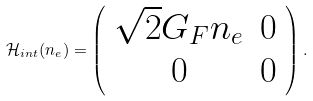<formula> <loc_0><loc_0><loc_500><loc_500>\mathcal { H } _ { i n t } ( n _ { e } ) = \left ( \begin{array} { c c } \sqrt { 2 } G _ { F } n _ { e } & 0 \\ 0 & 0 \end{array} \right ) .</formula> 